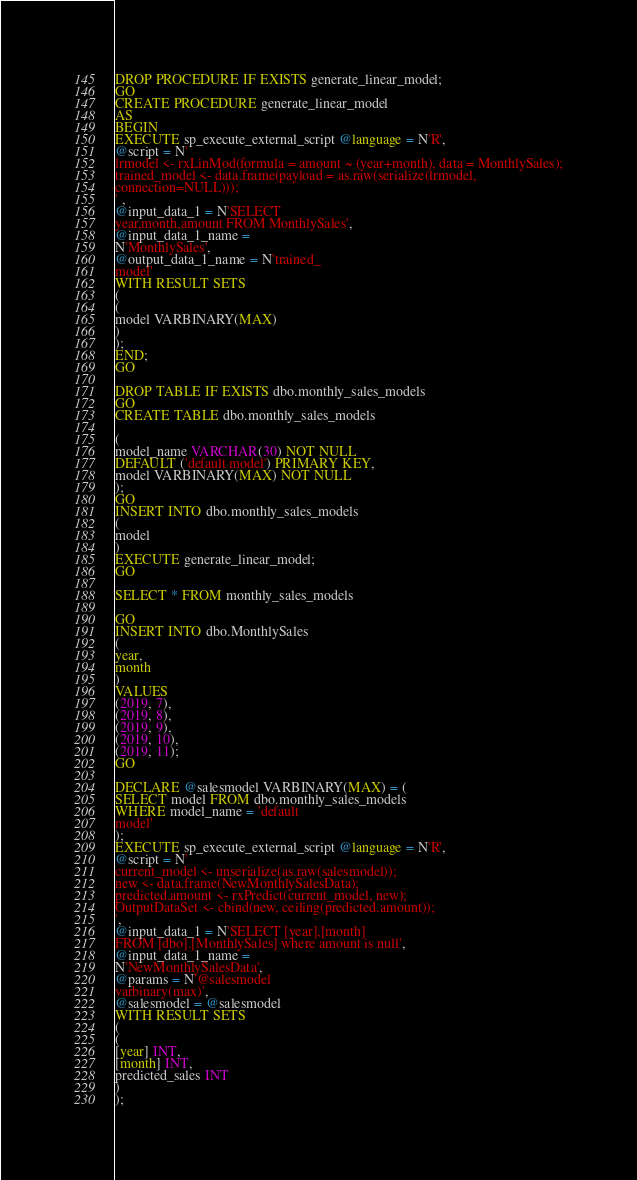Convert code to text. <code><loc_0><loc_0><loc_500><loc_500><_SQL_>DROP PROCEDURE IF EXISTS generate_linear_model;
GO
CREATE PROCEDURE generate_linear_model
AS
BEGIN
EXECUTE sp_execute_external_script @language = N'R',
@script = N'
lrmodel <- rxLinMod(formula = amount ~ (year+month), data = MonthlySales);
trained_model <- data.frame(payload = as.raw(serialize(lrmodel,
connection=NULL)));
' ,
@input_data_1 = N'SELECT
year,month,amount FROM MonthlySales',
@input_data_1_name =
N'MonthlySales',
@output_data_1_name = N'trained_
model'
WITH RESULT SETS
(
(
model VARBINARY(MAX)
)
);
END;
GO

DROP TABLE IF EXISTS dbo.monthly_sales_models
GO
CREATE TABLE dbo.monthly_sales_models

(
model_name VARCHAR(30) NOT NULL
DEFAULT ('default model') PRIMARY KEY,
model VARBINARY(MAX) NOT NULL
);
GO
INSERT INTO dbo.monthly_sales_models
(
model
)
EXECUTE generate_linear_model;
GO

SELECT * FROM monthly_sales_models

GO
INSERT INTO dbo.MonthlySales
(
year,
month
)
VALUES
(2019, 7),
(2019, 8),
(2019, 9),
(2019, 10),
(2019, 11);
GO

DECLARE @salesmodel VARBINARY(MAX) = (
SELECT model FROM dbo.monthly_sales_models
WHERE model_name = 'default
model'
);
EXECUTE sp_execute_external_script @language = N'R',
@script = N'
current_model <- unserialize(as.raw(salesmodel));
new <- data.frame(NewMonthlySalesData);
predicted.amount <- rxPredict(current_model, new);
OutputDataSet <- cbind(new, ceiling(predicted.amount));
',
@input_data_1 = N'SELECT [year],[month]
FROM [dbo].[MonthlySales] where amount is null',
@input_data_1_name =
N'NewMonthlySalesData',
@params = N'@salesmodel
varbinary(max)',
@salesmodel = @salesmodel
WITH RESULT SETS
(
(
[year] INT,
[month] INT,
predicted_sales INT
)
);</code> 